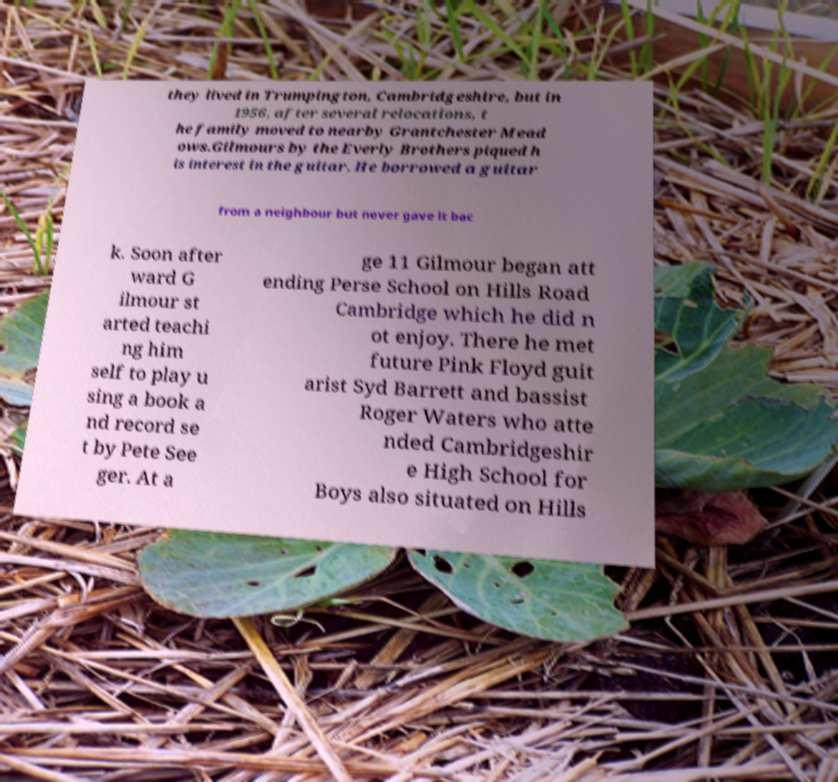I need the written content from this picture converted into text. Can you do that? they lived in Trumpington, Cambridgeshire, but in 1956, after several relocations, t he family moved to nearby Grantchester Mead ows.Gilmours by the Everly Brothers piqued h is interest in the guitar. He borrowed a guitar from a neighbour but never gave it bac k. Soon after ward G ilmour st arted teachi ng him self to play u sing a book a nd record se t by Pete See ger. At a ge 11 Gilmour began att ending Perse School on Hills Road Cambridge which he did n ot enjoy. There he met future Pink Floyd guit arist Syd Barrett and bassist Roger Waters who atte nded Cambridgeshir e High School for Boys also situated on Hills 